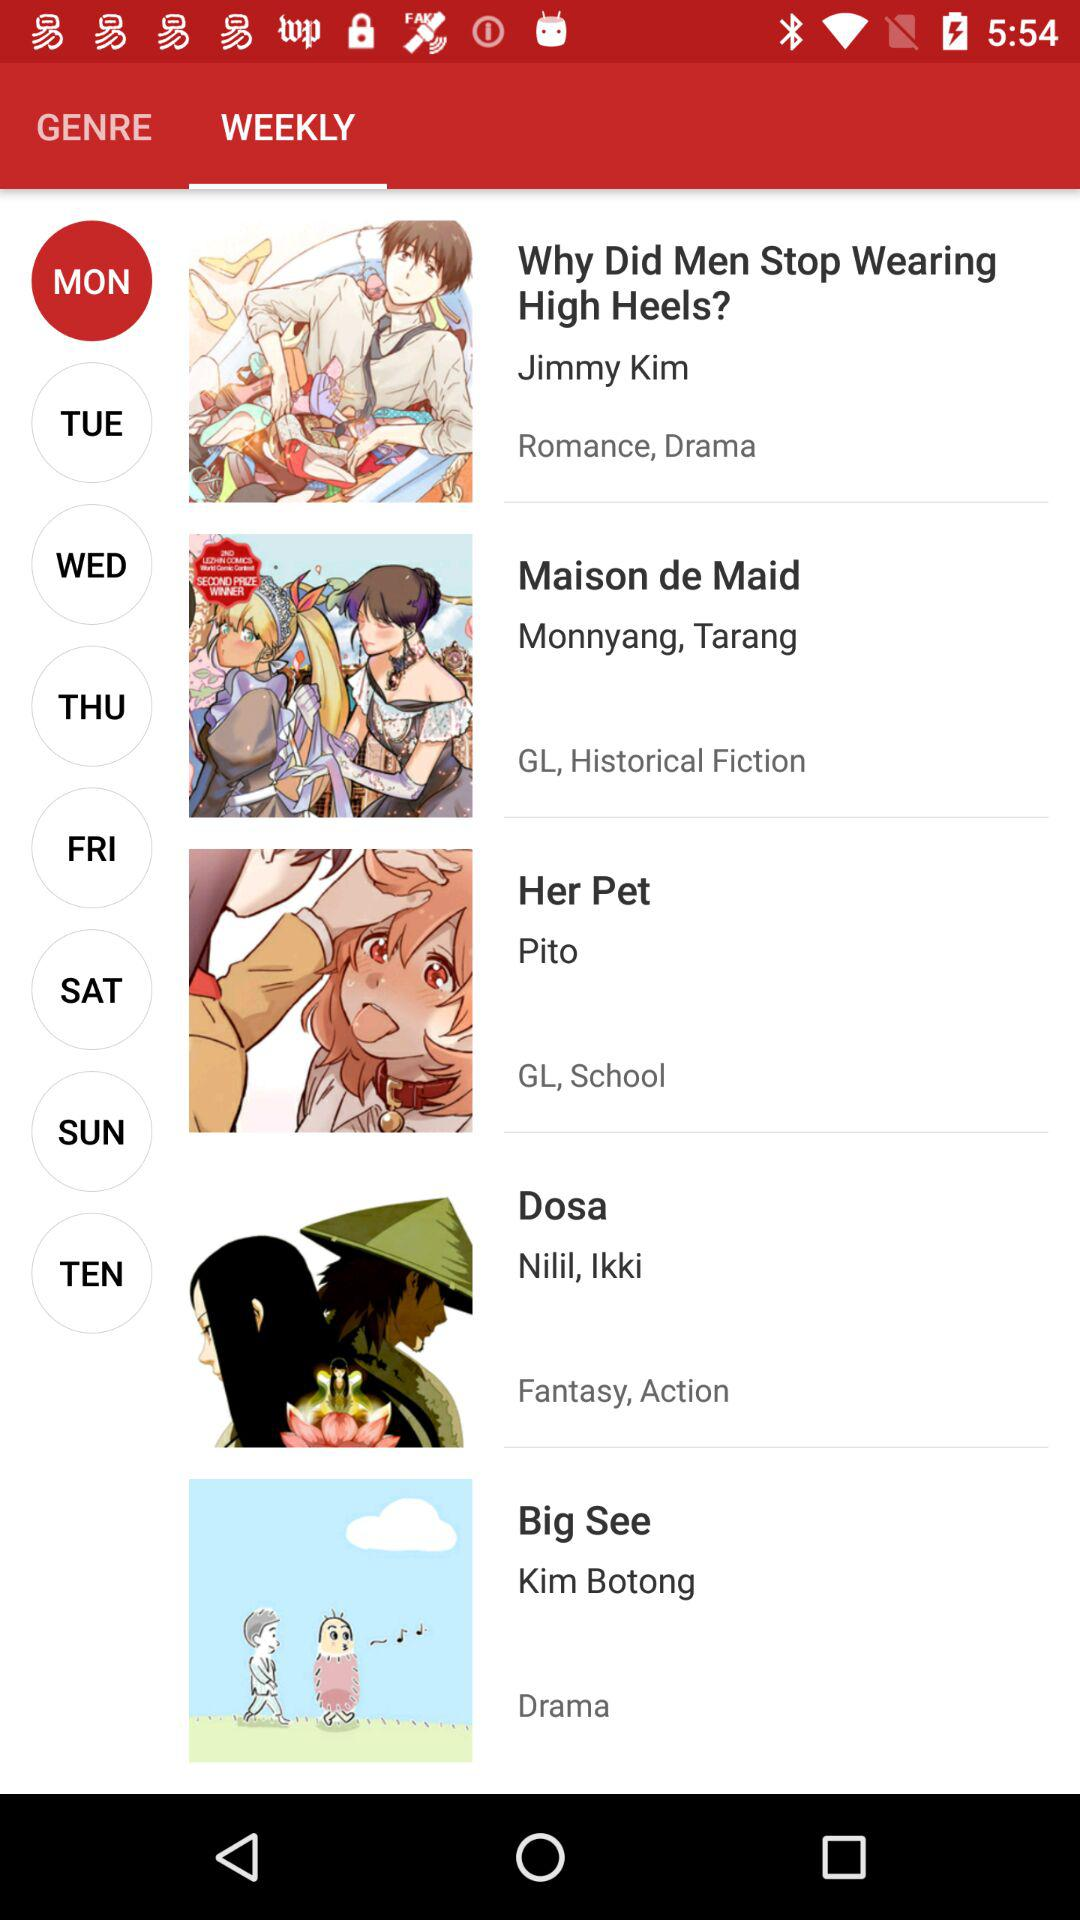Who is the author of the manga "Her Pet"? The author of the manga "Her Pet" is Pito. 